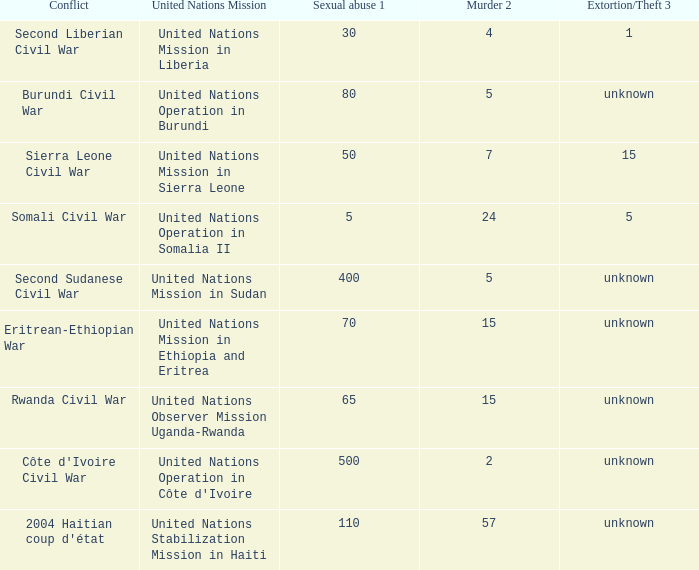What is the extortion and theft rates where the United Nations Observer Mission Uganda-Rwanda is active? Unknown. 